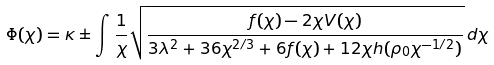Convert formula to latex. <formula><loc_0><loc_0><loc_500><loc_500>\Phi ( \chi ) = \kappa \pm \int \frac { 1 } { \chi } \sqrt { \frac { f ( \chi ) - 2 \chi V ( \chi ) } { 3 \lambda ^ { 2 } + 3 6 \chi ^ { 2 / 3 } + 6 f ( \chi ) + 1 2 \chi h ( \rho _ { 0 } \chi ^ { - 1 / 2 } ) } } \, d \chi</formula> 